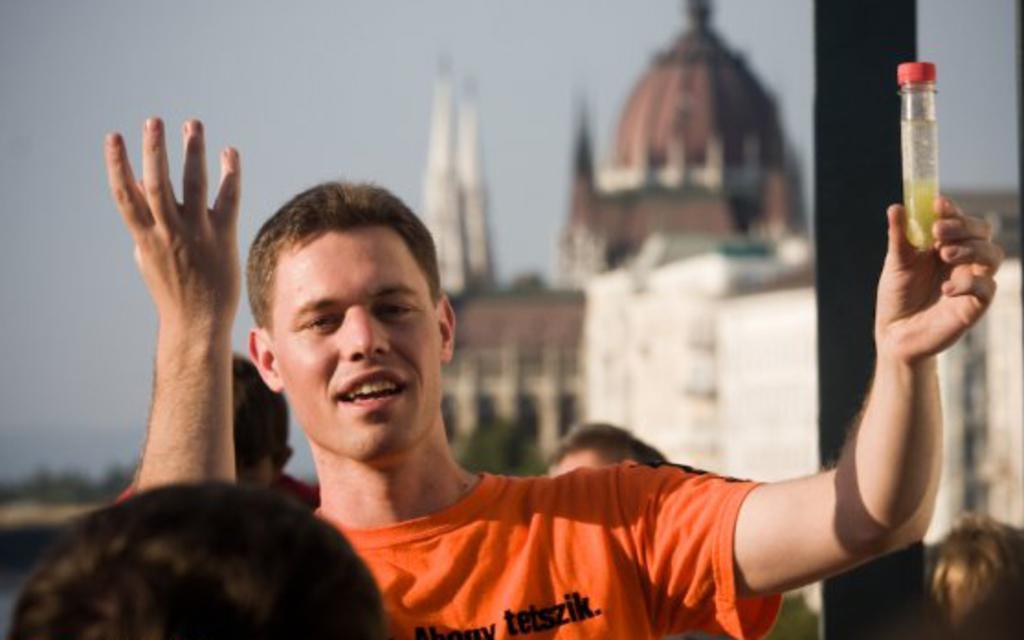Could you give a brief overview of what you see in this image? In this image we can see a few people, one of them is holding a bottle, there is a pole, a house, also we can see the sky, and the background is blurred. 